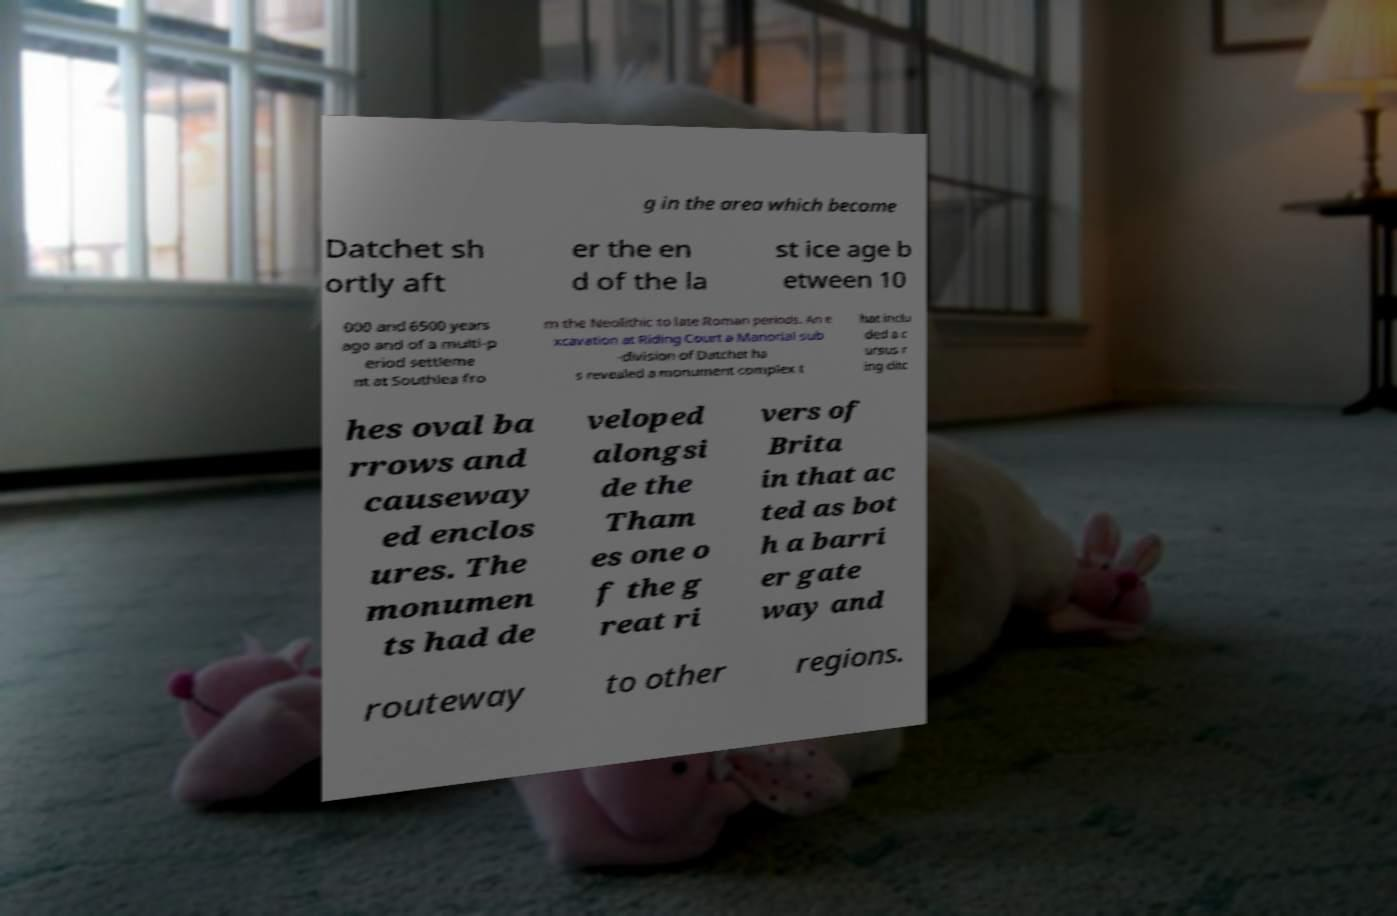Please read and relay the text visible in this image. What does it say? g in the area which become Datchet sh ortly aft er the en d of the la st ice age b etween 10 000 and 6500 years ago and of a multi-p eriod settleme nt at Southlea fro m the Neolithic to late Roman periods. An e xcavation at Riding Court a Manorial sub -division of Datchet ha s revealed a monument complex t hat inclu ded a c ursus r ing ditc hes oval ba rrows and causeway ed enclos ures. The monumen ts had de veloped alongsi de the Tham es one o f the g reat ri vers of Brita in that ac ted as bot h a barri er gate way and routeway to other regions. 